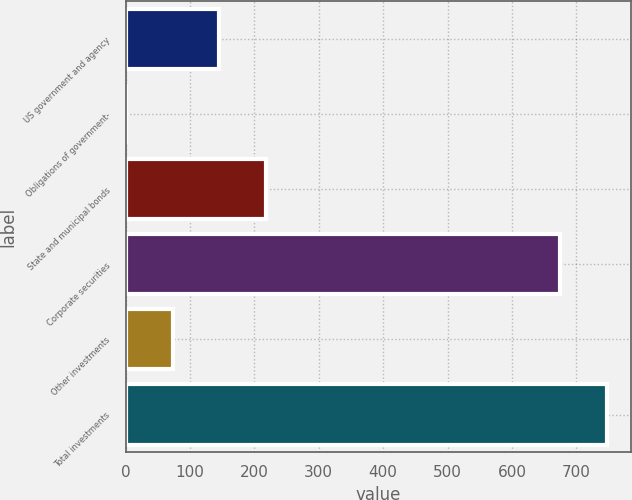Convert chart to OTSL. <chart><loc_0><loc_0><loc_500><loc_500><bar_chart><fcel>US government and agency<fcel>Obligations of government-<fcel>State and municipal bonds<fcel>Corporate securities<fcel>Other investments<fcel>Total investments<nl><fcel>145.4<fcel>1<fcel>217.6<fcel>675<fcel>73.2<fcel>747.2<nl></chart> 